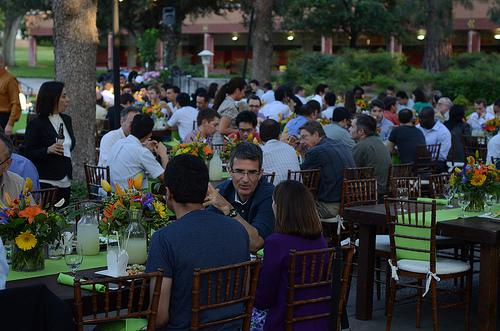Question: who is standing?
Choices:
A. The man in red.
B. The boy in a green sweater.
C. Woman in black blazer.
D. The little girl in a blue dress.
Answer with the letter. Answer: C Question: when was the picture taken?
Choices:
A. Daytime.
B. Night time.
C. After lunch.
D. During breakfast.
Answer with the letter. Answer: A Question: where are flowers?
Choices:
A. On tables.
B. In the ground.
C. In a greenhouse.
D. By the coffin.
Answer with the letter. Answer: A 